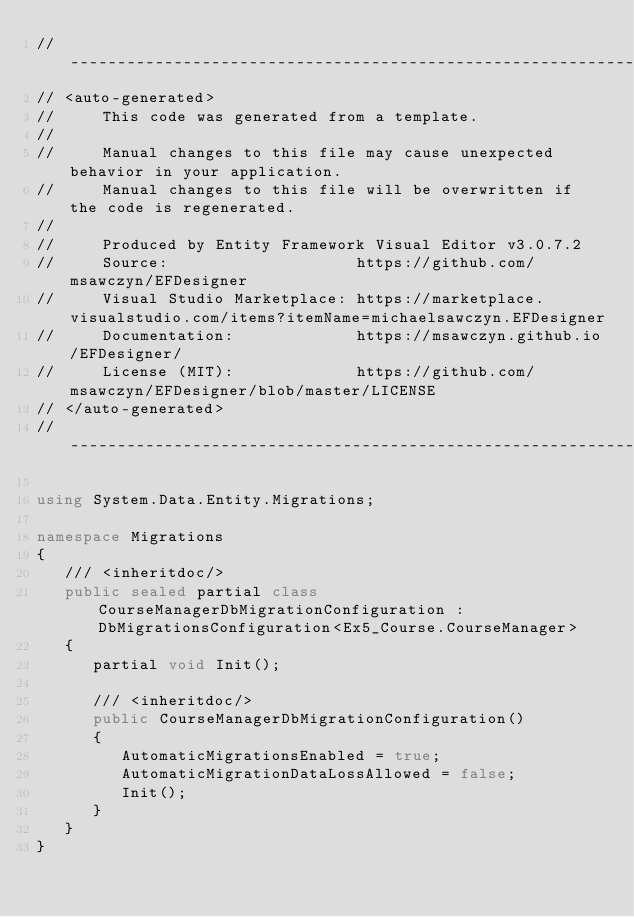<code> <loc_0><loc_0><loc_500><loc_500><_C#_>//------------------------------------------------------------------------------
// <auto-generated>
//     This code was generated from a template.
//
//     Manual changes to this file may cause unexpected behavior in your application.
//     Manual changes to this file will be overwritten if the code is regenerated.
//
//     Produced by Entity Framework Visual Editor v3.0.7.2
//     Source:                    https://github.com/msawczyn/EFDesigner
//     Visual Studio Marketplace: https://marketplace.visualstudio.com/items?itemName=michaelsawczyn.EFDesigner
//     Documentation:             https://msawczyn.github.io/EFDesigner/
//     License (MIT):             https://github.com/msawczyn/EFDesigner/blob/master/LICENSE
// </auto-generated>
//------------------------------------------------------------------------------

using System.Data.Entity.Migrations;

namespace Migrations
{
   /// <inheritdoc/>
   public sealed partial class CourseManagerDbMigrationConfiguration : DbMigrationsConfiguration<Ex5_Course.CourseManager>
   {
      partial void Init();

      /// <inheritdoc/>
      public CourseManagerDbMigrationConfiguration()
      {
         AutomaticMigrationsEnabled = true;
         AutomaticMigrationDataLossAllowed = false;
         Init();
      }
   }
}
</code> 